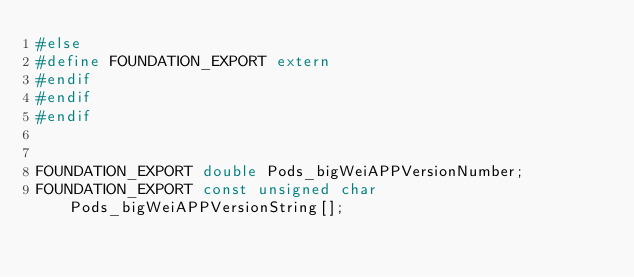<code> <loc_0><loc_0><loc_500><loc_500><_C_>#else
#define FOUNDATION_EXPORT extern
#endif
#endif
#endif


FOUNDATION_EXPORT double Pods_bigWeiAPPVersionNumber;
FOUNDATION_EXPORT const unsigned char Pods_bigWeiAPPVersionString[];

</code> 